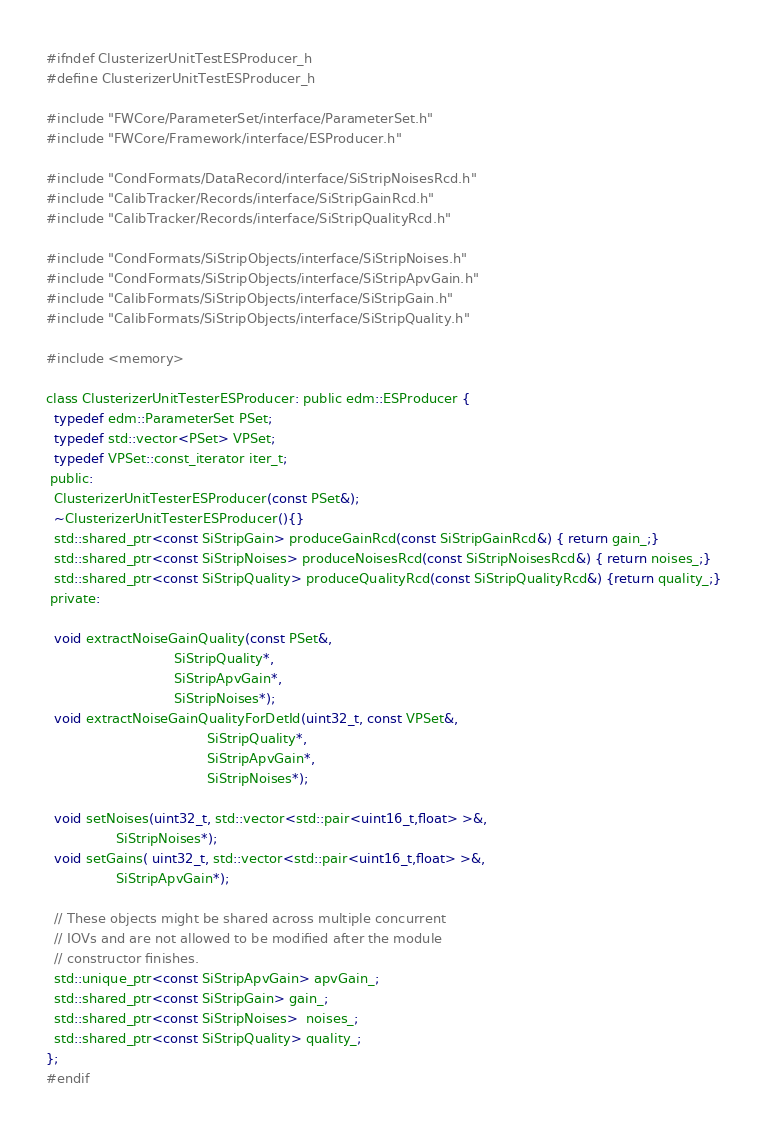Convert code to text. <code><loc_0><loc_0><loc_500><loc_500><_C_>#ifndef ClusterizerUnitTestESProducer_h
#define ClusterizerUnitTestESProducer_h

#include "FWCore/ParameterSet/interface/ParameterSet.h"
#include "FWCore/Framework/interface/ESProducer.h"

#include "CondFormats/DataRecord/interface/SiStripNoisesRcd.h"
#include "CalibTracker/Records/interface/SiStripGainRcd.h"
#include "CalibTracker/Records/interface/SiStripQualityRcd.h"

#include "CondFormats/SiStripObjects/interface/SiStripNoises.h"
#include "CondFormats/SiStripObjects/interface/SiStripApvGain.h"
#include "CalibFormats/SiStripObjects/interface/SiStripGain.h"
#include "CalibFormats/SiStripObjects/interface/SiStripQuality.h"

#include <memory>

class ClusterizerUnitTesterESProducer: public edm::ESProducer {
  typedef edm::ParameterSet PSet;
  typedef std::vector<PSet> VPSet;
  typedef VPSet::const_iterator iter_t;
 public:
  ClusterizerUnitTesterESProducer(const PSet&);
  ~ClusterizerUnitTesterESProducer(){}
  std::shared_ptr<const SiStripGain> produceGainRcd(const SiStripGainRcd&) { return gain_;}
  std::shared_ptr<const SiStripNoises> produceNoisesRcd(const SiStripNoisesRcd&) { return noises_;}
  std::shared_ptr<const SiStripQuality> produceQualityRcd(const SiStripQualityRcd&) {return quality_;}
 private:
  
  void extractNoiseGainQuality(const PSet&,
                               SiStripQuality*,
                               SiStripApvGain*,
                               SiStripNoises*);
  void extractNoiseGainQualityForDetId(uint32_t, const VPSet&,
                                       SiStripQuality*,
                                       SiStripApvGain*,
                                       SiStripNoises*);

  void setNoises(uint32_t, std::vector<std::pair<uint16_t,float> >&,
                 SiStripNoises*);
  void setGains( uint32_t, std::vector<std::pair<uint16_t,float> >&,
                 SiStripApvGain*);

  // These objects might be shared across multiple concurrent
  // IOVs and are not allowed to be modified after the module
  // constructor finishes.
  std::unique_ptr<const SiStripApvGain> apvGain_;
  std::shared_ptr<const SiStripGain> gain_;
  std::shared_ptr<const SiStripNoises>  noises_;
  std::shared_ptr<const SiStripQuality> quality_;
};
#endif
</code> 